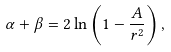Convert formula to latex. <formula><loc_0><loc_0><loc_500><loc_500>\alpha + \beta = 2 \ln \left ( 1 - \frac { A } { r ^ { 2 } } \right ) ,</formula> 